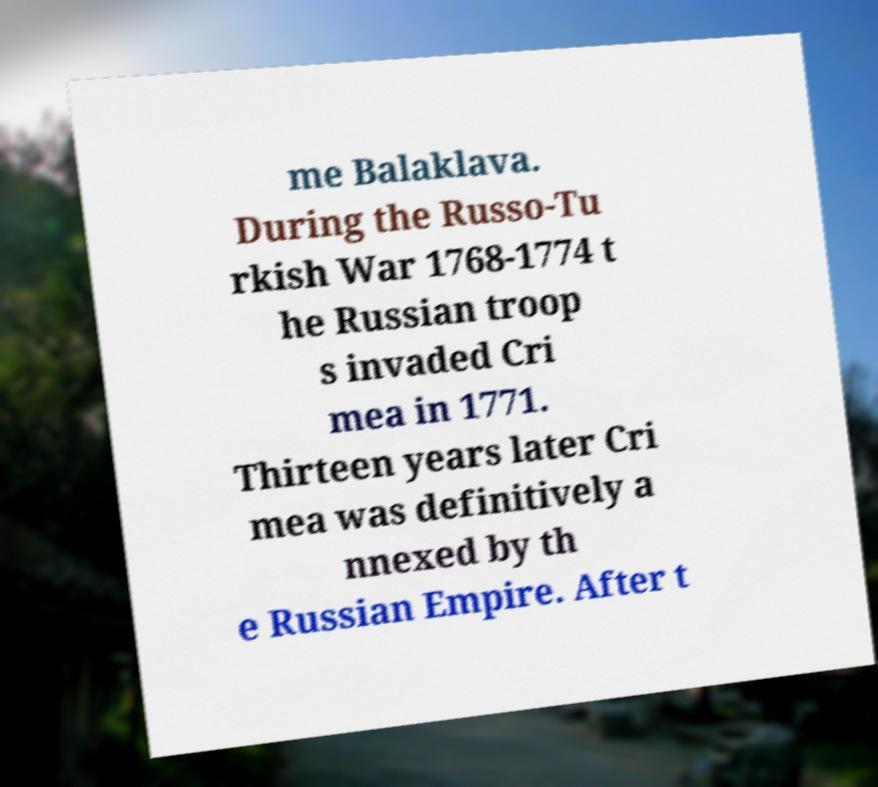Please identify and transcribe the text found in this image. me Balaklava. During the Russo-Tu rkish War 1768-1774 t he Russian troop s invaded Cri mea in 1771. Thirteen years later Cri mea was definitively a nnexed by th e Russian Empire. After t 